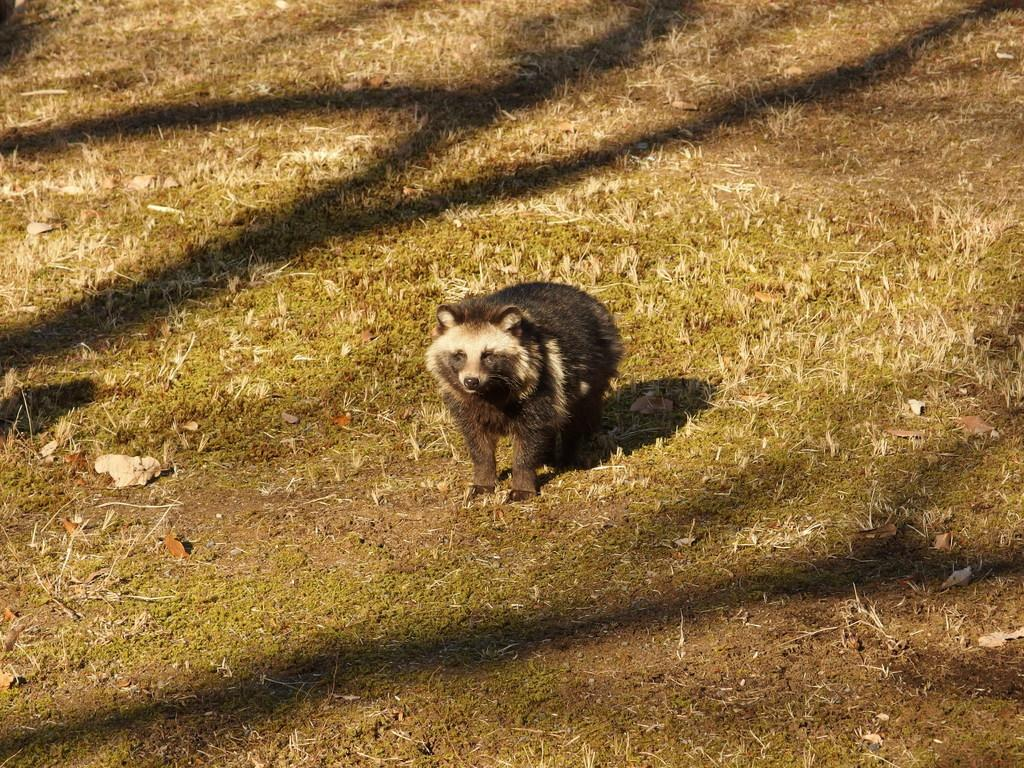What type of creature is in the image? There is an animal in the image. Can you describe the animal's position in the image? The animal is standing on the ground. What can be seen in the background of the image? There is grass visible in the background of the image. What type of brass instrument is the animal playing in the image? There is no brass instrument present in the image; it features an animal standing on the ground with grass visible in the background. 